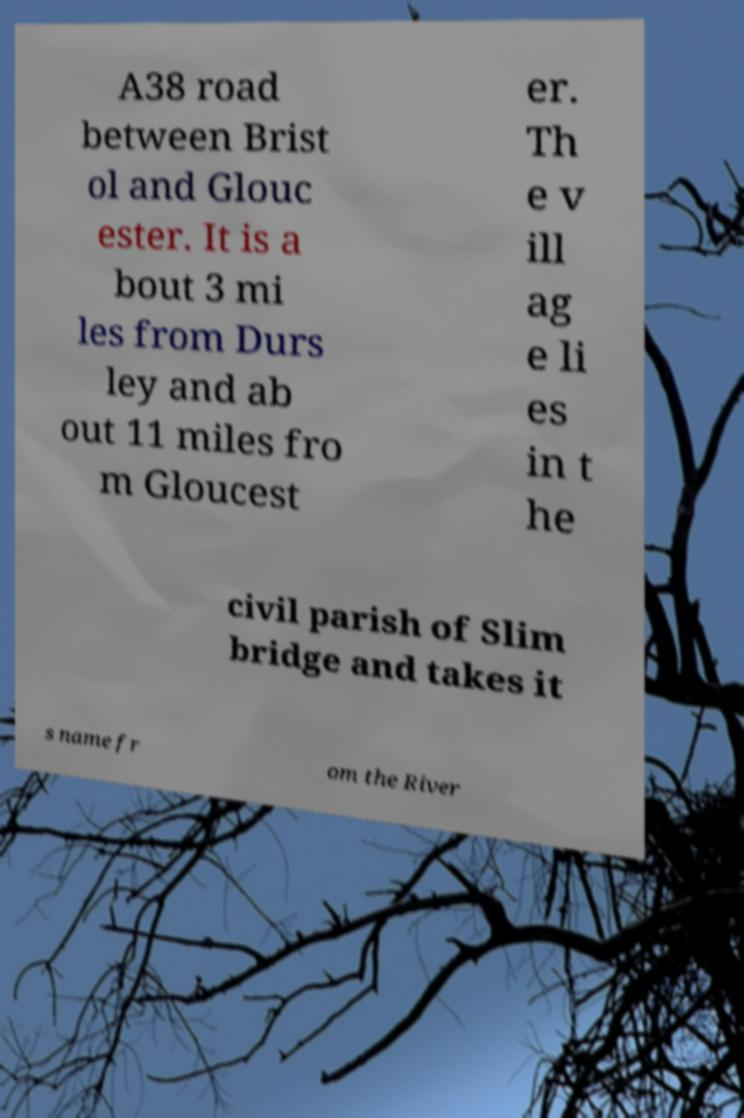Please read and relay the text visible in this image. What does it say? A38 road between Brist ol and Glouc ester. It is a bout 3 mi les from Durs ley and ab out 11 miles fro m Gloucest er. Th e v ill ag e li es in t he civil parish of Slim bridge and takes it s name fr om the River 